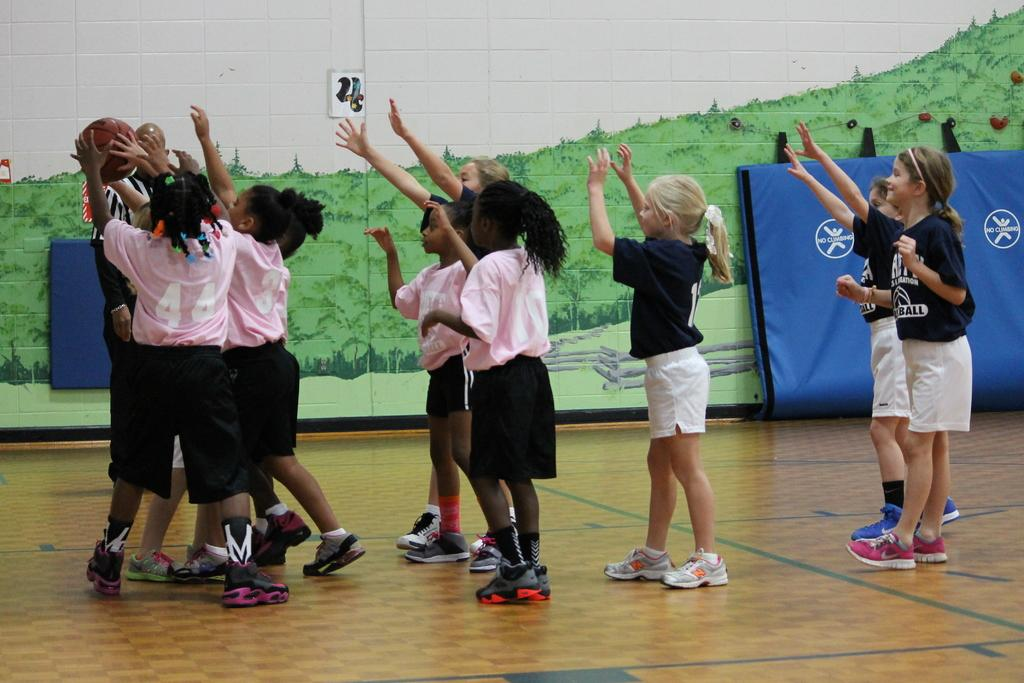What can be seen in the image? There are children in the image. Where are the children located? The children are standing on the floor. What are some children holding in the image? Some children are holding a ball. What is visible on the wall in the background? There is a painting on the wall in the background. What else can be seen in the background? There are other objects visible in the background. What type of sweater is the child wearing in the image? There is no mention of a sweater in the image. --- Facts: 1. There is a car in the image. 2. The car is red. 3. The car has four wheels. 4. There are people inside the car. 5. The car is parked on the street. Absurd Topics: unicorn, rainbow, magic wand Conversation: What is the main subject in the image? There is a car in the image. What color is the car? The car is red. How many wheels does the car have? The car has four wheels. Are there any people inside the car? Yes, there are people inside the car. Where is the car located? The car is parked on the street. Reasoning: Let's think step by step in order to produce the conversation. We start by identifying the main subject in the image, which is the car. Next, we describe the car's color, which is red. Then, we mention the number of wheels the car has, which is four. After that, we acknowledge the presence of people inside the car. Finally, we describe the car's location, which is parked on the street. Absurd Question/Answer: Can you see a unicorn in the image? No, there is no unicorn present in the image. --- Facts: 1. There is a dog in the image. 2. The dog is brown. 3. The dog is wagging its tail. 4. There is a bone in front of the dog. 5. The dog is sitting on the grass. Absurd Topics: flying carpet, genie lamp, magic carpet Conversation: What type of animal can be seen in the image? There is a dog in the image. What color is the dog? The dog is brown. What is the dog doing in the image? The dog is wagging its tail. What object is in front of the dog? There is a bone in front of the dog. Where is the dog located? The dog is sitting on the grass. Reasoning: Let's think step by step in order to produce the conversation. We start by identifying the main subject in the image, which is the dog. Next, we describe the dog's color, which is brown. Then, we mention the dog's action, which is wagging its tail. After 